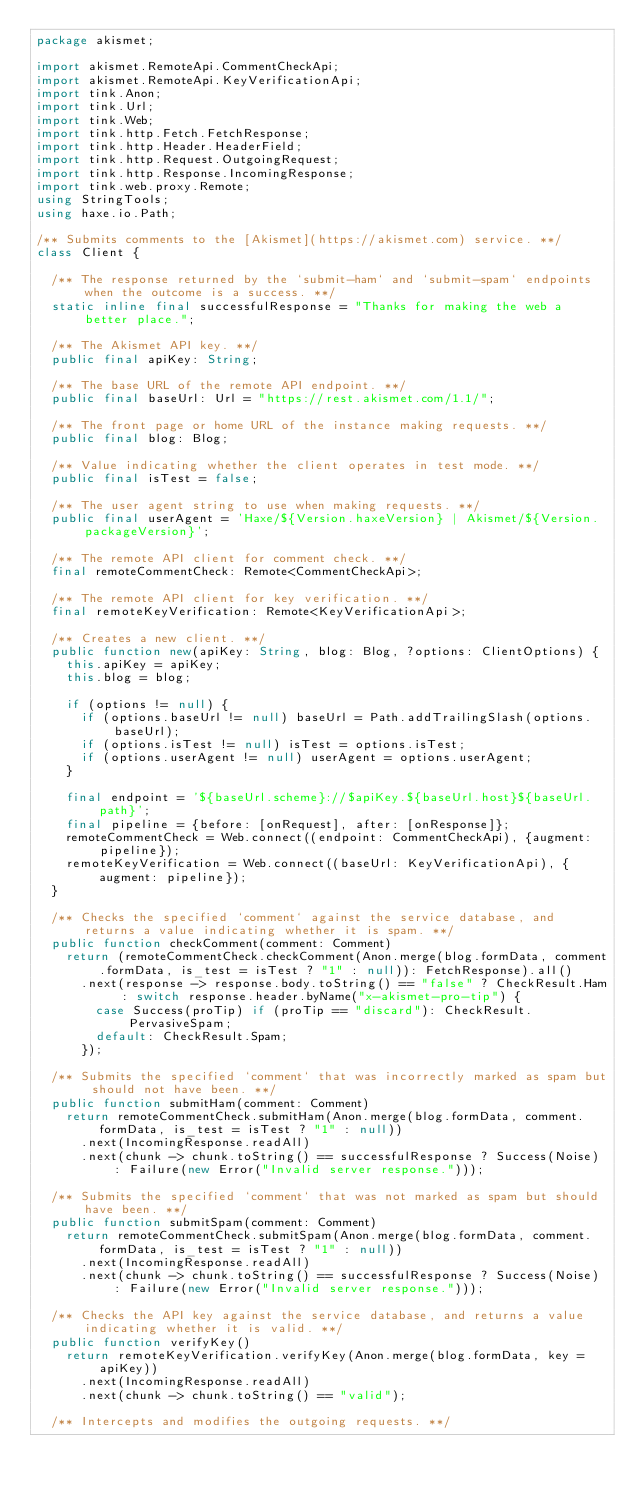Convert code to text. <code><loc_0><loc_0><loc_500><loc_500><_Haxe_>package akismet;

import akismet.RemoteApi.CommentCheckApi;
import akismet.RemoteApi.KeyVerificationApi;
import tink.Anon;
import tink.Url;
import tink.Web;
import tink.http.Fetch.FetchResponse;
import tink.http.Header.HeaderField;
import tink.http.Request.OutgoingRequest;
import tink.http.Response.IncomingResponse;
import tink.web.proxy.Remote;
using StringTools;
using haxe.io.Path;

/** Submits comments to the [Akismet](https://akismet.com) service. **/
class Client {

	/** The response returned by the `submit-ham` and `submit-spam` endpoints when the outcome is a success. **/
	static inline final successfulResponse = "Thanks for making the web a better place.";

	/** The Akismet API key. **/
	public final apiKey: String;

	/** The base URL of the remote API endpoint. **/
	public final baseUrl: Url = "https://rest.akismet.com/1.1/";

	/** The front page or home URL of the instance making requests. **/
	public final blog: Blog;

	/** Value indicating whether the client operates in test mode. **/
	public final isTest = false;

	/** The user agent string to use when making requests. **/
	public final userAgent = 'Haxe/${Version.haxeVersion} | Akismet/${Version.packageVersion}';

	/** The remote API client for comment check. **/
	final remoteCommentCheck: Remote<CommentCheckApi>;

	/** The remote API client for key verification. **/
	final remoteKeyVerification: Remote<KeyVerificationApi>;

	/** Creates a new client. **/
	public function new(apiKey: String, blog: Blog, ?options: ClientOptions) {
		this.apiKey = apiKey;
		this.blog = blog;

		if (options != null) {
			if (options.baseUrl != null) baseUrl = Path.addTrailingSlash(options.baseUrl);
			if (options.isTest != null) isTest = options.isTest;
			if (options.userAgent != null) userAgent = options.userAgent;
		}

		final endpoint = '${baseUrl.scheme}://$apiKey.${baseUrl.host}${baseUrl.path}';
		final pipeline = {before: [onRequest], after: [onResponse]};
		remoteCommentCheck = Web.connect((endpoint: CommentCheckApi), {augment: pipeline});
		remoteKeyVerification = Web.connect((baseUrl: KeyVerificationApi), {augment: pipeline});
	}

	/** Checks the specified `comment` against the service database, and returns a value indicating whether it is spam. **/
	public function checkComment(comment: Comment)
		return (remoteCommentCheck.checkComment(Anon.merge(blog.formData, comment.formData, is_test = isTest ? "1" : null)): FetchResponse).all()
			.next(response -> response.body.toString() == "false" ? CheckResult.Ham : switch response.header.byName("x-akismet-pro-tip") {
				case Success(proTip) if (proTip == "discard"): CheckResult.PervasiveSpam;
				default: CheckResult.Spam;
			});

	/** Submits the specified `comment` that was incorrectly marked as spam but should not have been. **/
	public function submitHam(comment: Comment)
		return remoteCommentCheck.submitHam(Anon.merge(blog.formData, comment.formData, is_test = isTest ? "1" : null))
			.next(IncomingResponse.readAll)
			.next(chunk -> chunk.toString() == successfulResponse ? Success(Noise) : Failure(new Error("Invalid server response.")));

	/** Submits the specified `comment` that was not marked as spam but should have been. **/
	public function submitSpam(comment: Comment)
		return remoteCommentCheck.submitSpam(Anon.merge(blog.formData, comment.formData, is_test = isTest ? "1" : null))
			.next(IncomingResponse.readAll)
			.next(chunk -> chunk.toString() == successfulResponse ? Success(Noise) : Failure(new Error("Invalid server response.")));

	/** Checks the API key against the service database, and returns a value indicating whether it is valid. **/
	public function verifyKey()
		return remoteKeyVerification.verifyKey(Anon.merge(blog.formData, key = apiKey))
			.next(IncomingResponse.readAll)
			.next(chunk -> chunk.toString() == "valid");

	/** Intercepts and modifies the outgoing requests. **/</code> 